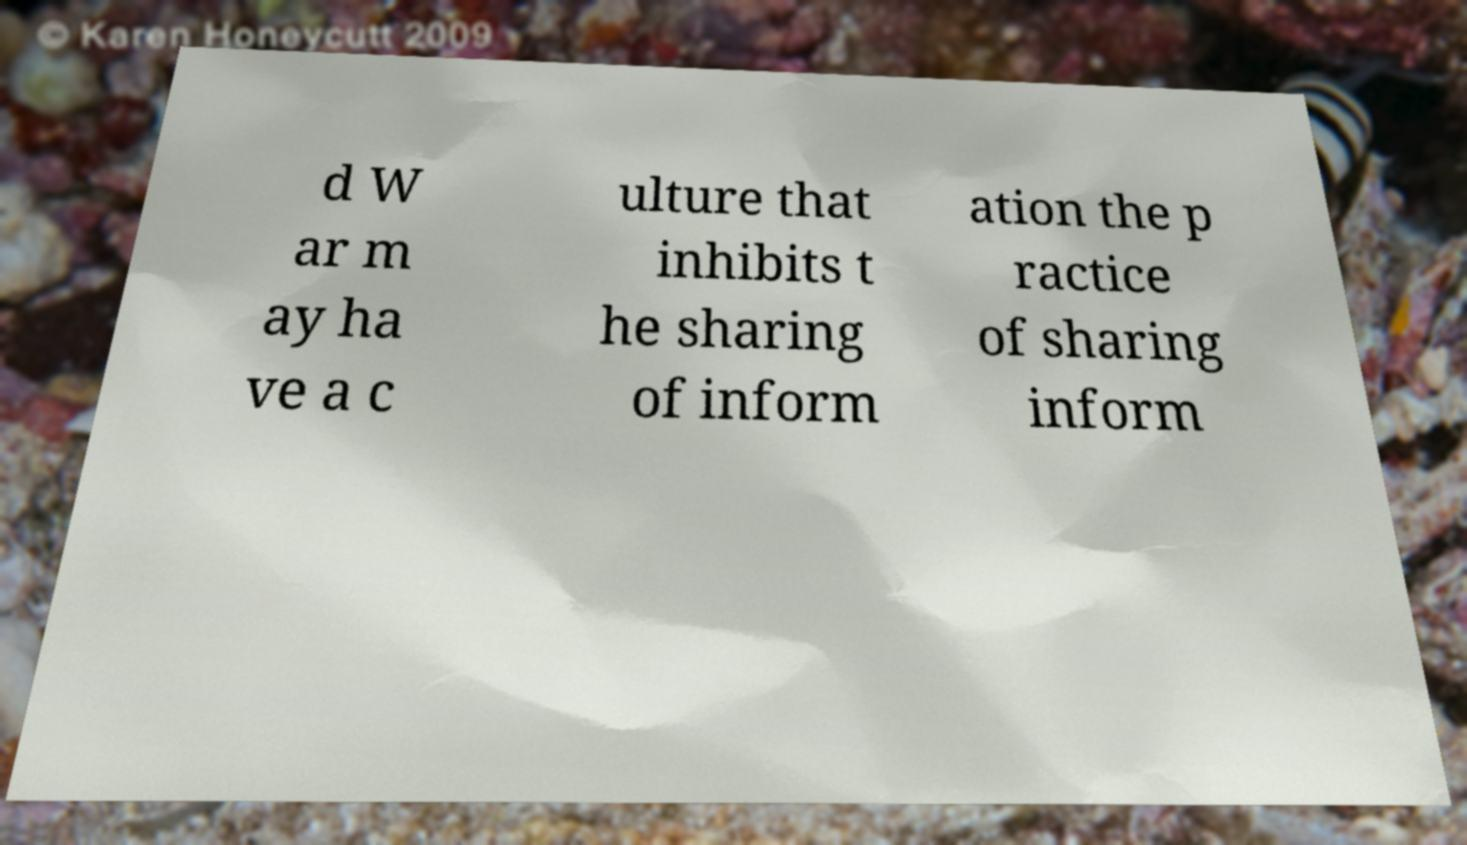For documentation purposes, I need the text within this image transcribed. Could you provide that? d W ar m ay ha ve a c ulture that inhibits t he sharing of inform ation the p ractice of sharing inform 